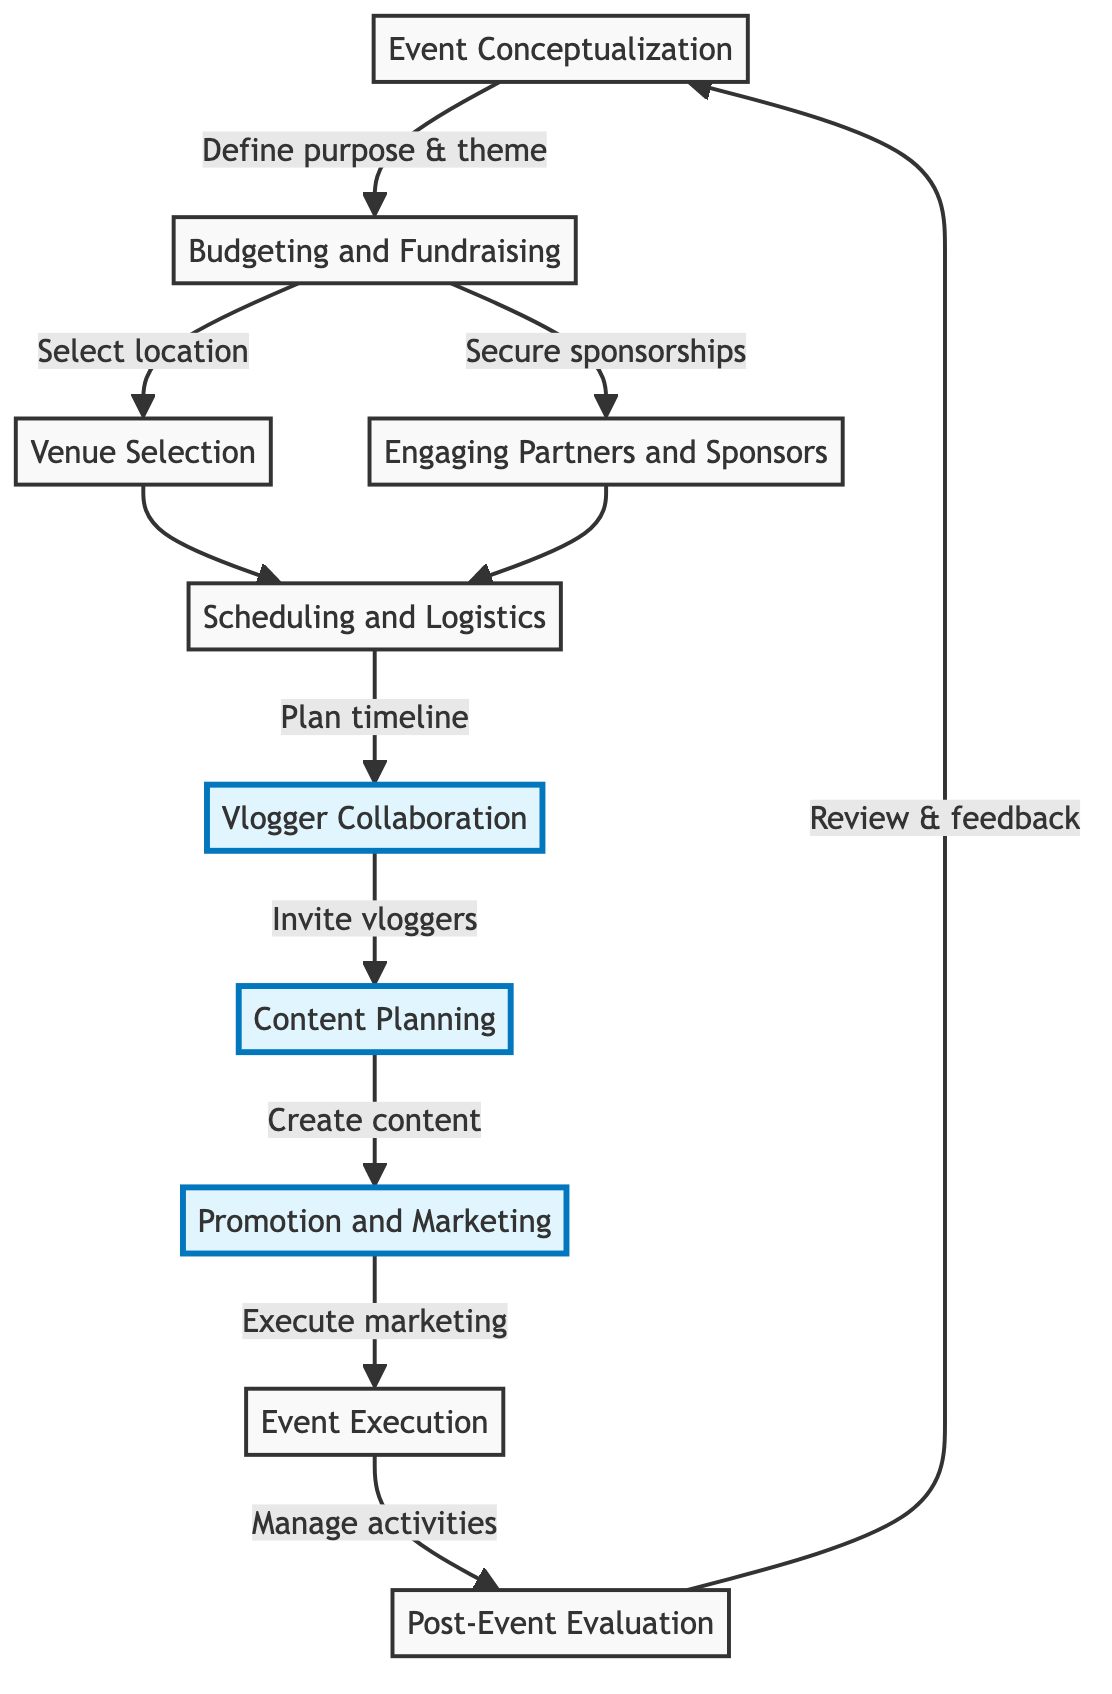What is the first step in the process? The diagram indicates that the first step is "Event Conceptualization," which defines the purpose, theme, and objectives of the local event.
Answer: Event Conceptualization How many main blocks are there in the diagram? By counting the blocks listed in the diagram, we find there are ten distinct blocks representing different stages in the local event planning process.
Answer: Ten What follows "Scheduling and Logistics"? After "Scheduling and Logistics," the next block in the process is "Vlogger Collaboration," which involves identifying and inviting local vloggers for promotion.
Answer: Vlogger Collaboration Which block is focused on fundraising opportunities? The block dedicated to this is "Budgeting and Fundraising," where the budget is determined and fundraising opportunities are explored.
Answer: Budgeting and Fundraising Which two blocks come after "Vlogger Collaboration"? Following "Vlogger Collaboration," the process moves to "Content Planning," and then to "Promotion and Marketing," as they are sequentially connected in the diagram.
Answer: Content Planning, Promotion and Marketing What is the purpose of the "Post-Event Evaluation" block? The purpose of this block is to review the event outcomes and gather feedback to assess the overall success and areas for improvement following the event.
Answer: Review outcomes Which blocks directly lead to "Scheduling and Logistics"? The blocks that directly lead to "Scheduling and Logistics" are "Venue Selection" and "Engaging Partners and Sponsors," as they both flow into this stage.
Answer: Venue Selection, Engaging Partners and Sponsors What activity is associated with "Content Planning"? The activity associated with "Content Planning" involves coordinating with vloggers to create promotional content that can be used in marketing the event.
Answer: Create promotional content What is the final step before the process loops back to the beginning? The final step before returning to the beginning of the process is "Post-Event Evaluation," where the successes and feedback from the event are reviewed.
Answer: Post-Event Evaluation 